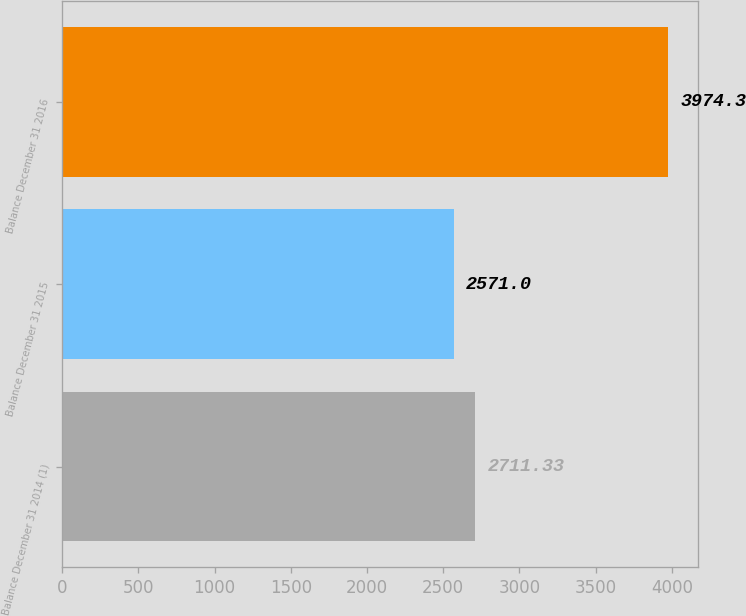Convert chart. <chart><loc_0><loc_0><loc_500><loc_500><bar_chart><fcel>Balance December 31 2014 (1)<fcel>Balance December 31 2015<fcel>Balance December 31 2016<nl><fcel>2711.33<fcel>2571<fcel>3974.3<nl></chart> 